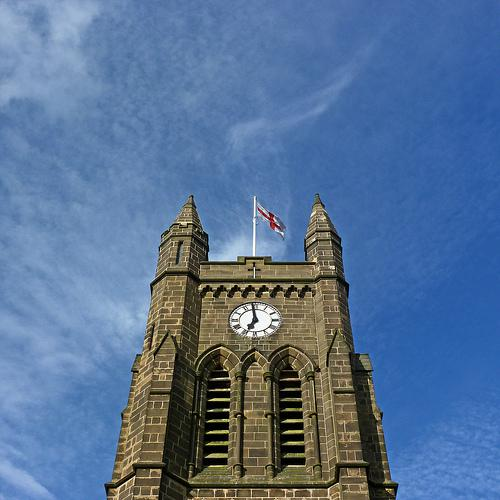Question: why is the clock there?
Choices:
A. To tell time.
B. For decoration.
C. For an alarm clock.
D. To use as a timer.
Answer with the letter. Answer: A Question: what is on the tower?
Choices:
A. A light.
B. A antenne.
C. A clock.
D. A window.
Answer with the letter. Answer: C Question: when was the photo taken?
Choices:
A. Night time.
B. During the day.
C. Early morning.
D. Evening.
Answer with the letter. Answer: B Question: what time is it?
Choices:
A. 8:05.
B. 12:00.
C. 7:59.
D. 4:37.
Answer with the letter. Answer: C Question: where are the clouds?
Choices:
A. Behind the trees.
B. In the sky.
C. Over the mountains.
D. Outside the plane window.
Answer with the letter. Answer: B 